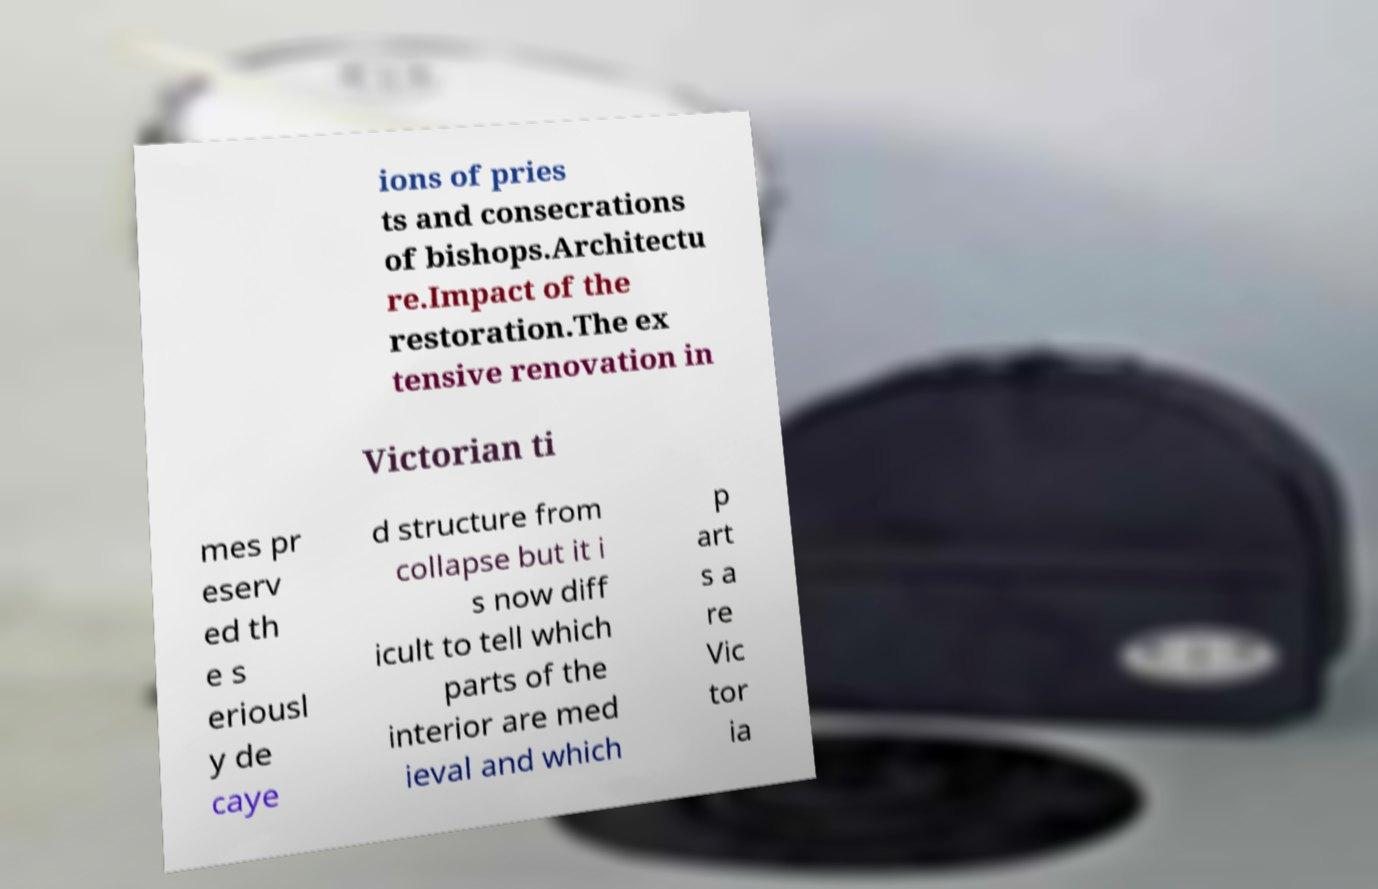What messages or text are displayed in this image? I need them in a readable, typed format. ions of pries ts and consecrations of bishops.Architectu re.Impact of the restoration.The ex tensive renovation in Victorian ti mes pr eserv ed th e s eriousl y de caye d structure from collapse but it i s now diff icult to tell which parts of the interior are med ieval and which p art s a re Vic tor ia 